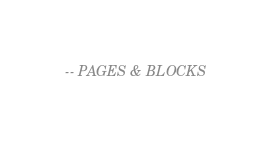<code> <loc_0><loc_0><loc_500><loc_500><_SQL_>-- PAGES & BLOCKS</code> 